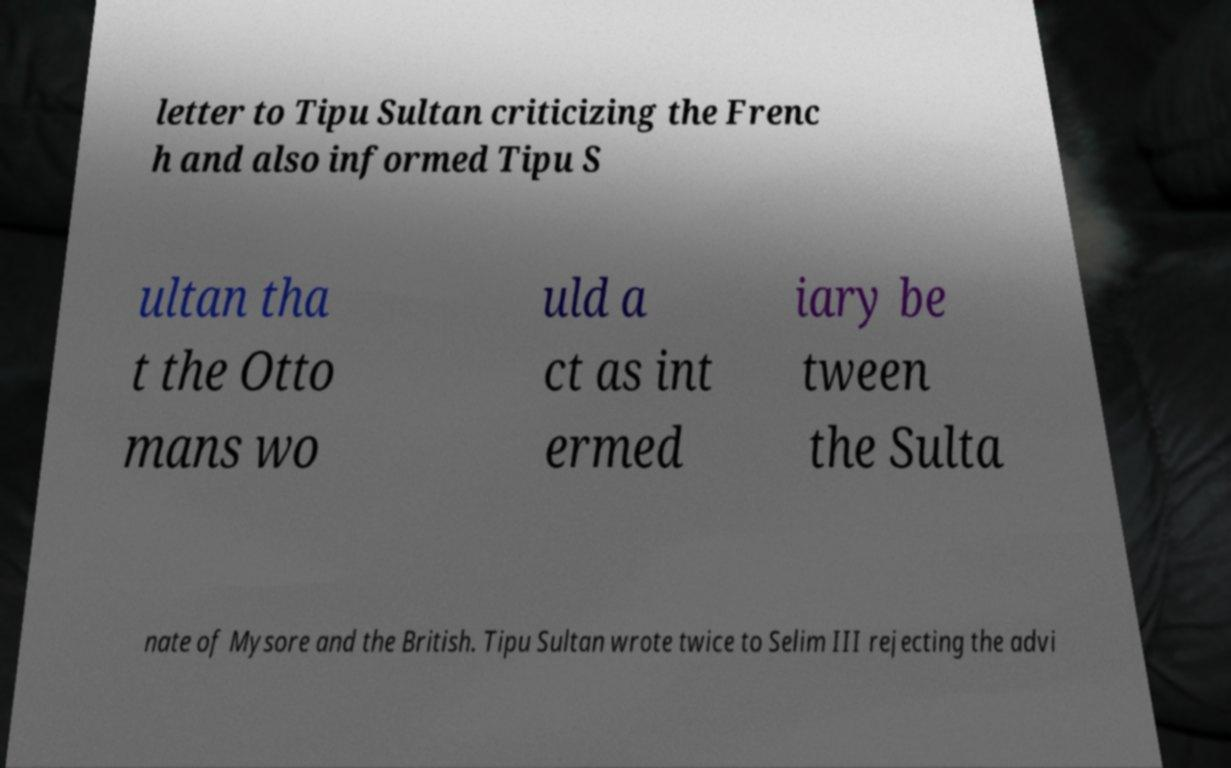Can you accurately transcribe the text from the provided image for me? letter to Tipu Sultan criticizing the Frenc h and also informed Tipu S ultan tha t the Otto mans wo uld a ct as int ermed iary be tween the Sulta nate of Mysore and the British. Tipu Sultan wrote twice to Selim III rejecting the advi 